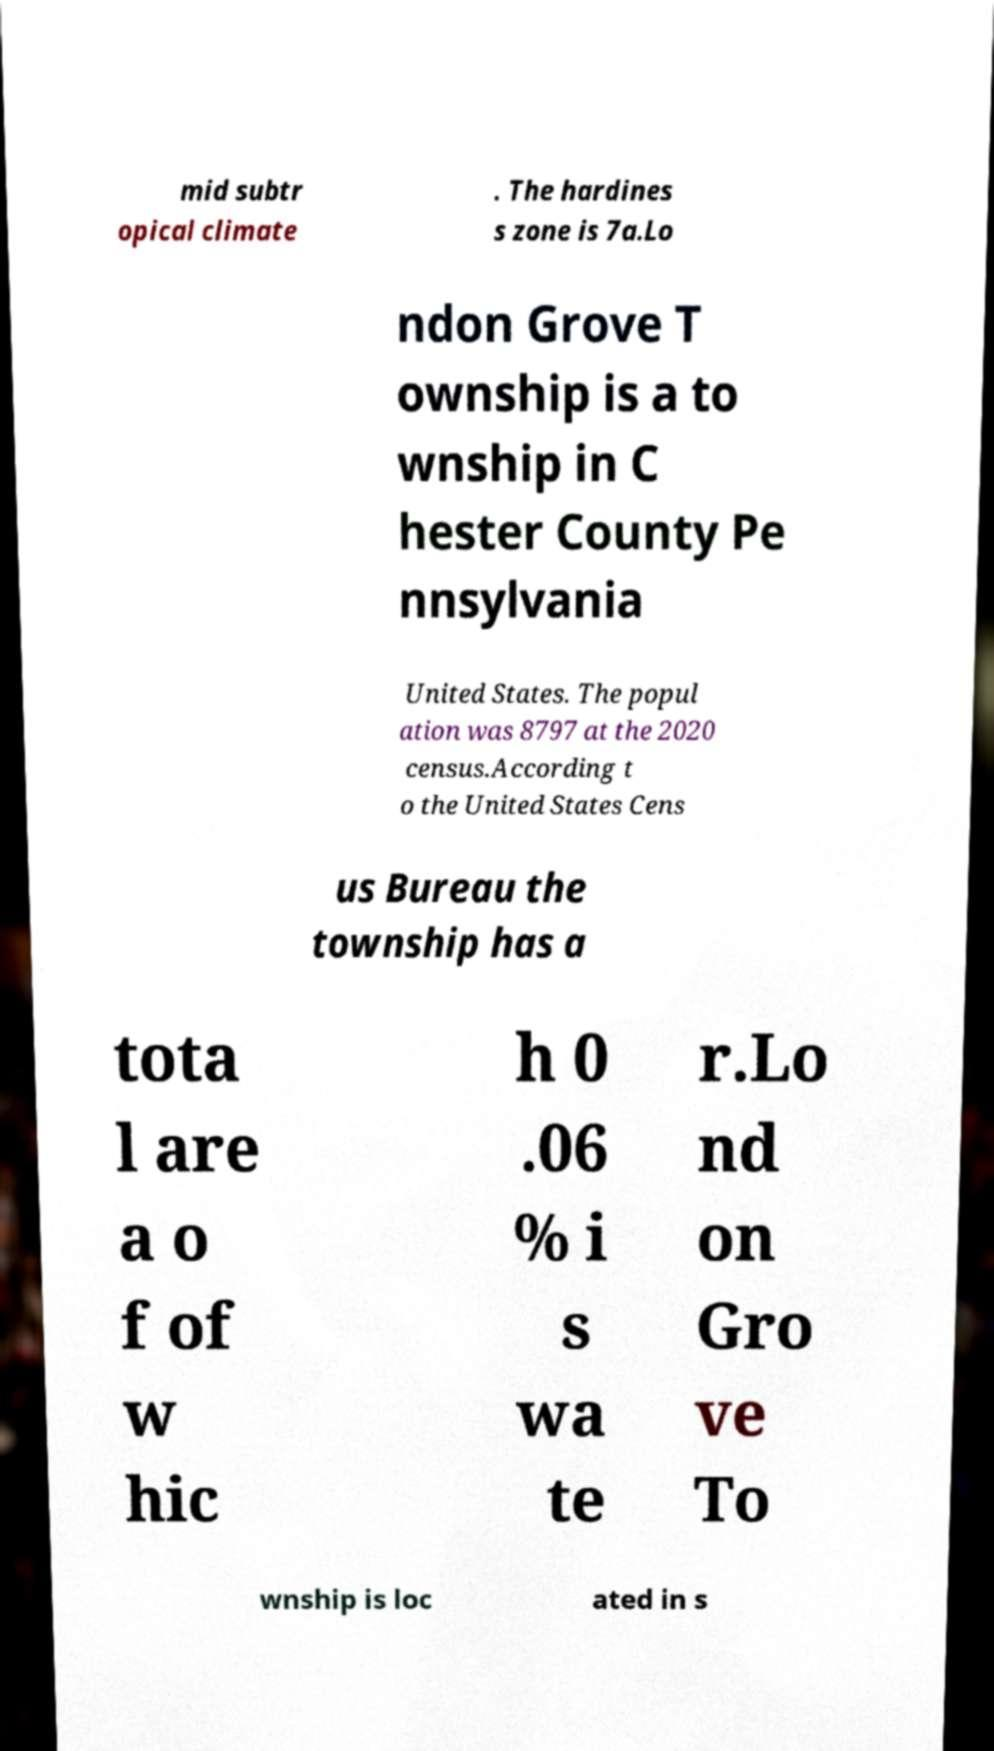For documentation purposes, I need the text within this image transcribed. Could you provide that? mid subtr opical climate . The hardines s zone is 7a.Lo ndon Grove T ownship is a to wnship in C hester County Pe nnsylvania United States. The popul ation was 8797 at the 2020 census.According t o the United States Cens us Bureau the township has a tota l are a o f of w hic h 0 .06 % i s wa te r.Lo nd on Gro ve To wnship is loc ated in s 